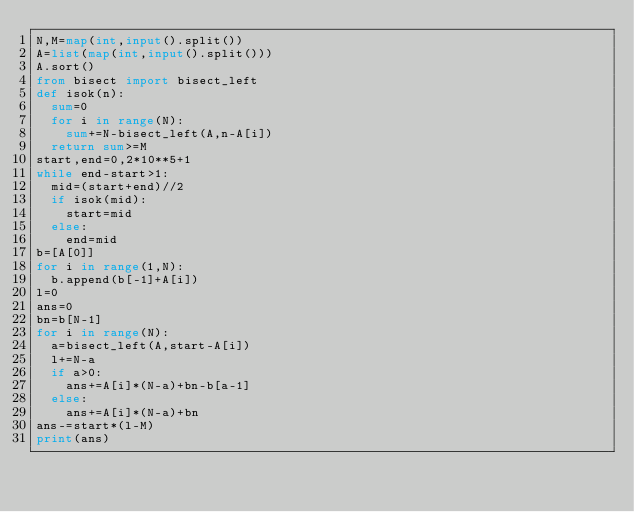Convert code to text. <code><loc_0><loc_0><loc_500><loc_500><_Python_>N,M=map(int,input().split())
A=list(map(int,input().split()))
A.sort()
from bisect import bisect_left
def isok(n):
  sum=0
  for i in range(N):
    sum+=N-bisect_left(A,n-A[i])
  return sum>=M
start,end=0,2*10**5+1
while end-start>1:
  mid=(start+end)//2
  if isok(mid):
    start=mid
  else:
    end=mid
b=[A[0]]
for i in range(1,N):
  b.append(b[-1]+A[i])
l=0
ans=0
bn=b[N-1]
for i in range(N):
  a=bisect_left(A,start-A[i])
  l+=N-a
  if a>0:
    ans+=A[i]*(N-a)+bn-b[a-1]
  else:
    ans+=A[i]*(N-a)+bn
ans-=start*(l-M)
print(ans) </code> 